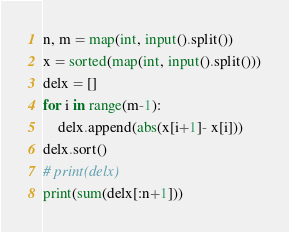<code> <loc_0><loc_0><loc_500><loc_500><_Python_>n, m = map(int, input().split())
x = sorted(map(int, input().split()))
delx = []
for i in range(m-1):
    delx.append(abs(x[i+1]- x[i]))
delx.sort()
# print(delx)
print(sum(delx[:n+1]))</code> 